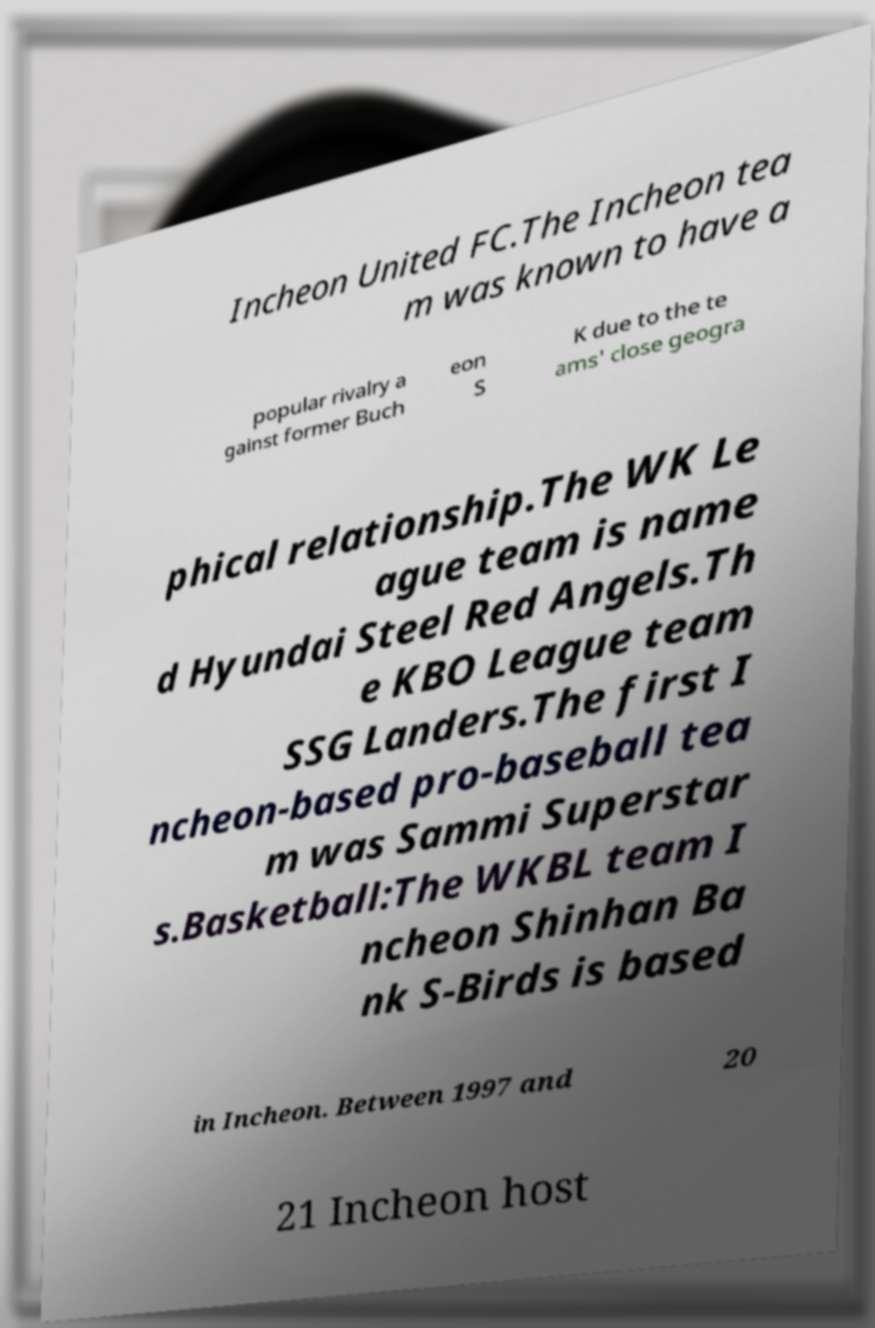Please read and relay the text visible in this image. What does it say? Incheon United FC.The Incheon tea m was known to have a popular rivalry a gainst former Buch eon S K due to the te ams' close geogra phical relationship.The WK Le ague team is name d Hyundai Steel Red Angels.Th e KBO League team SSG Landers.The first I ncheon-based pro-baseball tea m was Sammi Superstar s.Basketball:The WKBL team I ncheon Shinhan Ba nk S-Birds is based in Incheon. Between 1997 and 20 21 Incheon host 